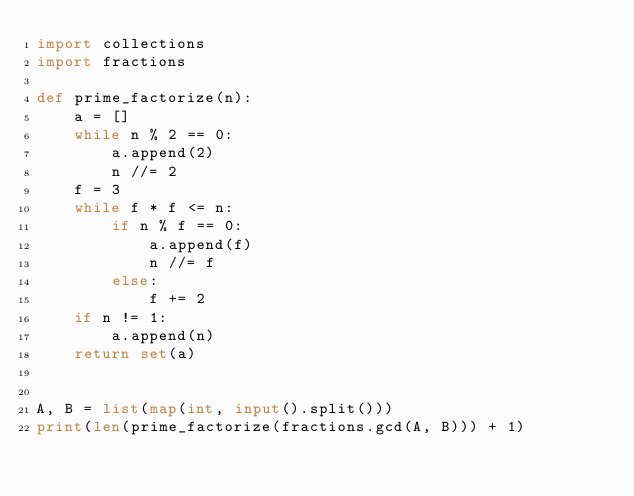<code> <loc_0><loc_0><loc_500><loc_500><_Python_>import collections
import fractions

def prime_factorize(n):
    a = []
    while n % 2 == 0:
        a.append(2)
        n //= 2
    f = 3
    while f * f <= n:
        if n % f == 0:
            a.append(f)
            n //= f
        else:
            f += 2
    if n != 1:
        a.append(n)
    return set(a)


A, B = list(map(int, input().split()))
print(len(prime_factorize(fractions.gcd(A, B))) + 1)
</code> 